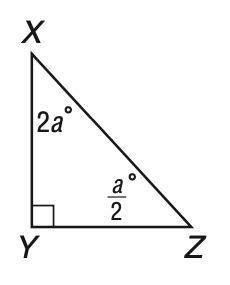Question: In the triangle, what is the measure of \angle Z?
Choices:
A. 18
B. 24
C. 72
D. 90
Answer with the letter. Answer: A 